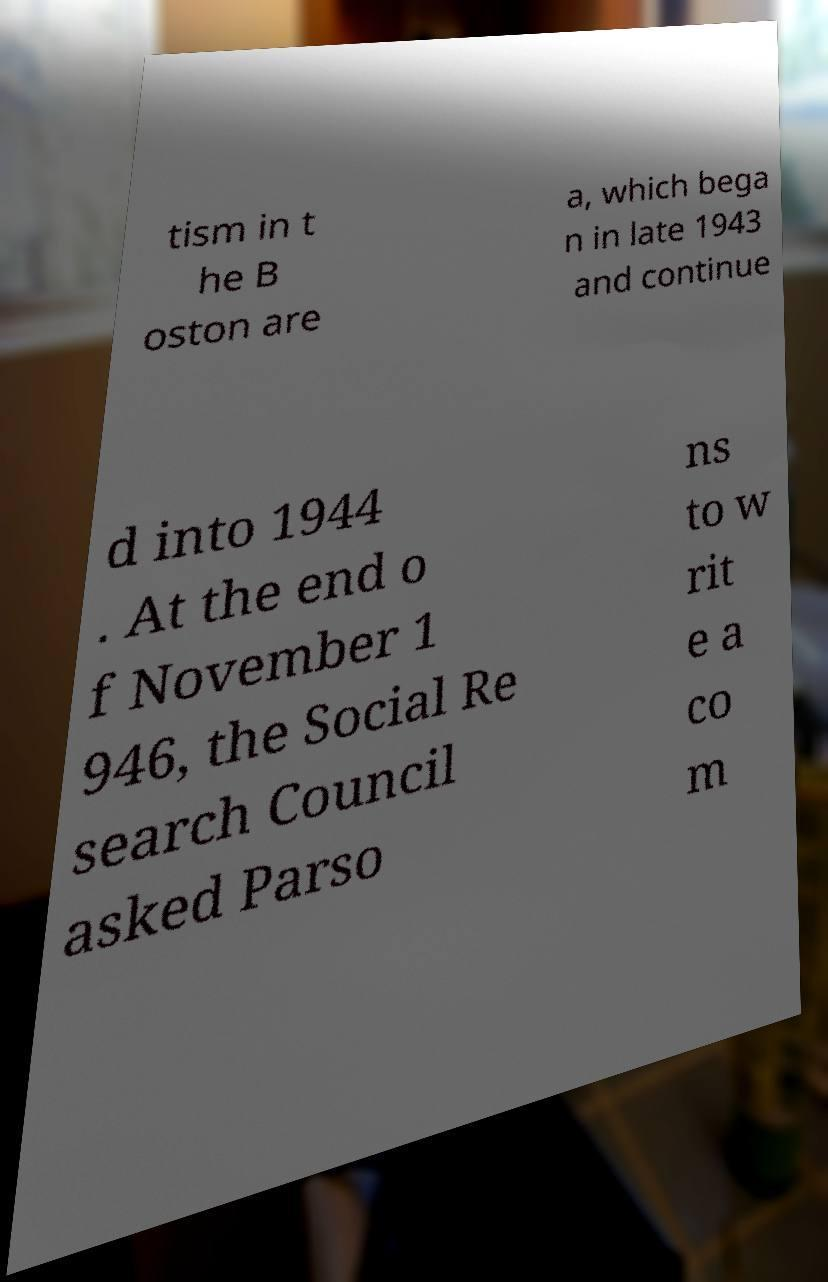Could you extract and type out the text from this image? tism in t he B oston are a, which bega n in late 1943 and continue d into 1944 . At the end o f November 1 946, the Social Re search Council asked Parso ns to w rit e a co m 